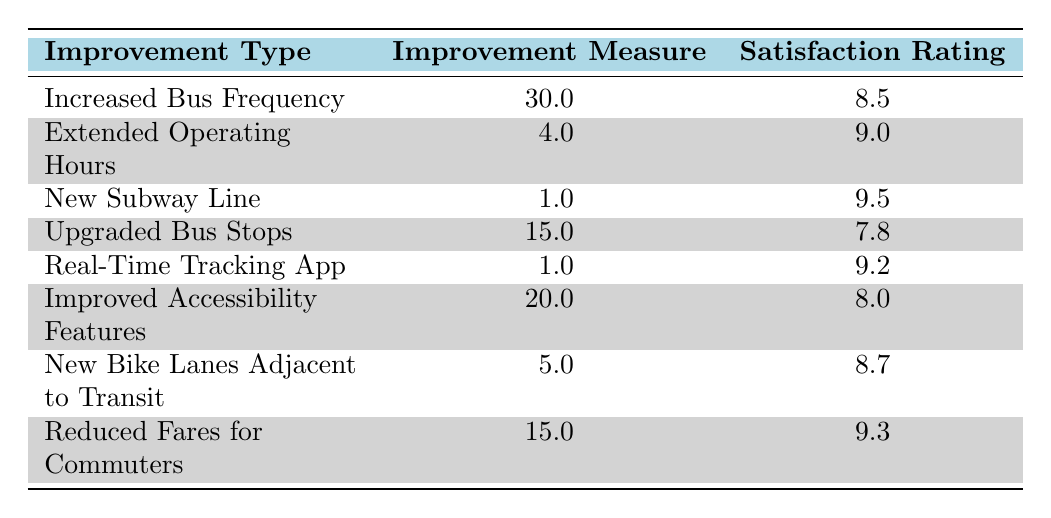What is the satisfaction rating for the "New Subway Line"? From the table, we can directly see the satisfaction rating listed next to the "New Subway Line," which is 9.5.
Answer: 9.5 How many improvement types have a satisfaction rating above 9? We can scan the satisfaction ratings in the table and see that there are three improvement types with ratings above 9: "Extended Operating Hours" (9.0), "New Subway Line" (9.5), "Real-Time Tracking App" (9.2), and "Reduced Fares for Commuters" (9.3). Counting these gives us a total of 4.
Answer: 4 What is the improvement measure for "Reduced Fares for Commuters"? In the table, under the improvement type "Reduced Fares for Commuters," the improvement measure listed is 15.0.
Answer: 15.0 Is the satisfaction rating for "Upgraded Bus Stops" greater than 8? Checking the table, the satisfaction rating for "Upgraded Bus Stops" is 7.8, which is not greater than 8. Thus, the answer is no.
Answer: No What is the average satisfaction rating of all the improvements listed? To find the average satisfaction rating, we need to sum all ratings: (8.5 + 9.0 + 9.5 + 7.8 + 9.2 + 8.0 + 8.7 + 9.3) = 70.0. Then divide by the number of improvements, which is 8. Thus, the average is 70.0/8 = 8.75.
Answer: 8.75 How much did the "Increased Bus Frequency" improve commuter satisfaction compared to "Upgraded Bus Stops"? The satisfaction rating for "Increased Bus Frequency" is 8.5 and for "Upgraded Bus Stops" it is 7.8. The difference in satisfaction is 8.5 - 7.8 = 0.7, indicating improved satisfaction.
Answer: 0.7 Which improvement measured resulted in the highest satisfaction rating? From the table, we compare the satisfaction ratings and see that "New Subway Line" has the highest rating at 9.5.
Answer: New Subway Line How many improvements have a satisfaction rating of 8 or below? Reviewing the table, we see that there are three improvements with ratings of 8 or below: "Upgraded Bus Stops" (7.8), "Improved Accessibility Features" (8.0), and the other improvements are above 8. Hence, the total count is 2.
Answer: 2 